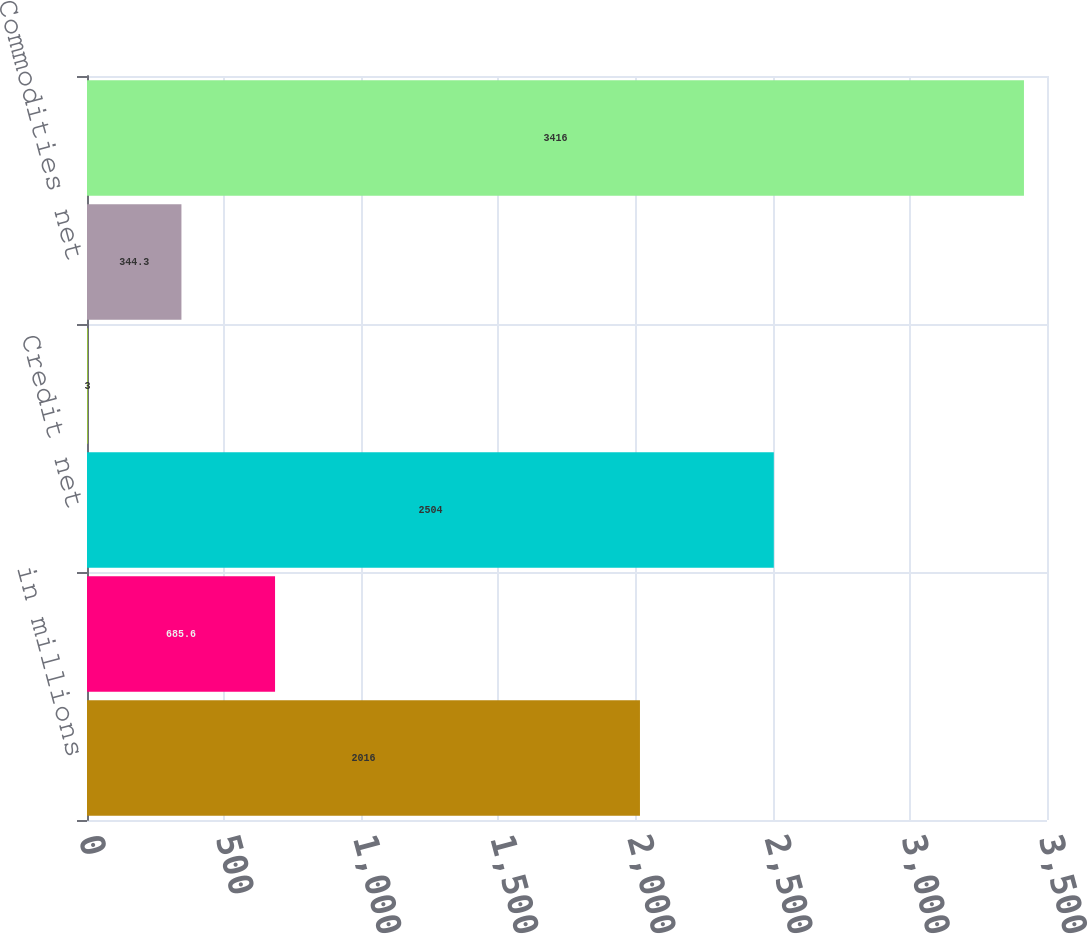Convert chart. <chart><loc_0><loc_0><loc_500><loc_500><bar_chart><fcel>in millions<fcel>Interest rates net<fcel>Credit net<fcel>Currencies net<fcel>Commodities net<fcel>E q uities net<nl><fcel>2016<fcel>685.6<fcel>2504<fcel>3<fcel>344.3<fcel>3416<nl></chart> 